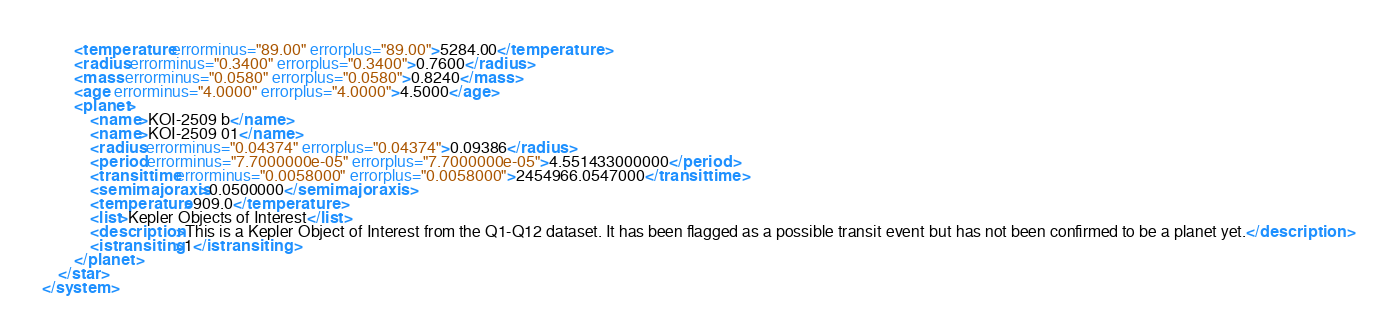Convert code to text. <code><loc_0><loc_0><loc_500><loc_500><_XML_>		<temperature errorminus="89.00" errorplus="89.00">5284.00</temperature>
		<radius errorminus="0.3400" errorplus="0.3400">0.7600</radius>
		<mass errorminus="0.0580" errorplus="0.0580">0.8240</mass>
		<age errorminus="4.0000" errorplus="4.0000">4.5000</age>
		<planet>
			<name>KOI-2509 b</name>
			<name>KOI-2509 01</name>
			<radius errorminus="0.04374" errorplus="0.04374">0.09386</radius>
			<period errorminus="7.7000000e-05" errorplus="7.7000000e-05">4.551433000000</period>
			<transittime errorminus="0.0058000" errorplus="0.0058000">2454966.0547000</transittime>
			<semimajoraxis>0.0500000</semimajoraxis>
			<temperature>909.0</temperature>
			<list>Kepler Objects of Interest</list>
			<description>This is a Kepler Object of Interest from the Q1-Q12 dataset. It has been flagged as a possible transit event but has not been confirmed to be a planet yet.</description>
			<istransiting>1</istransiting>
		</planet>
	</star>
</system>
</code> 